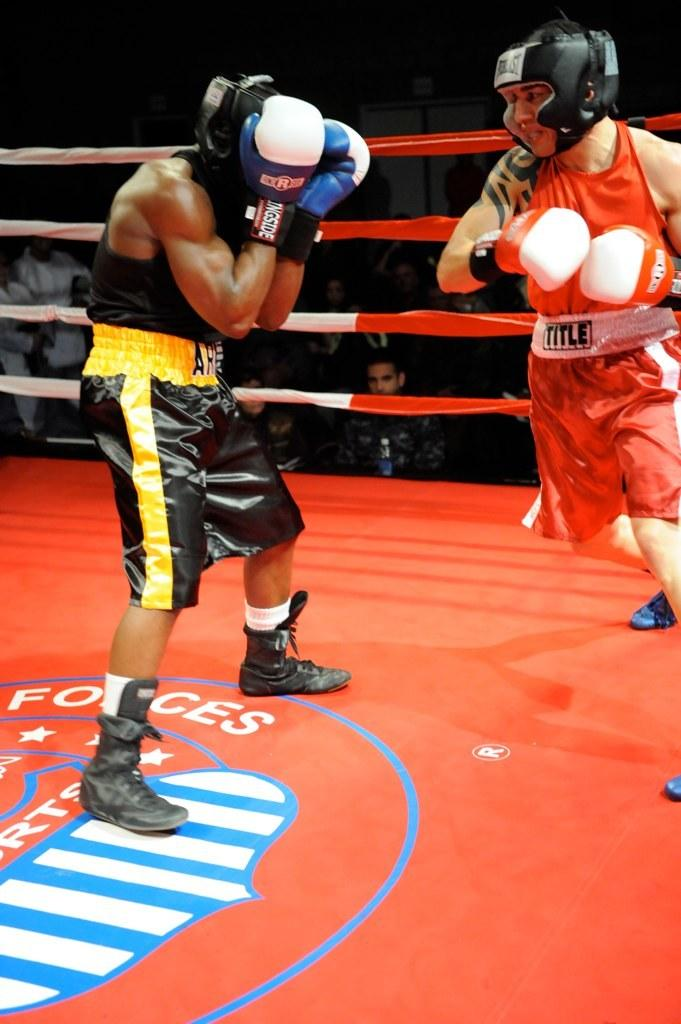<image>
Create a compact narrative representing the image presented. boxer wearing red title trunks going against guy that has ar on his black and yellow trunks 